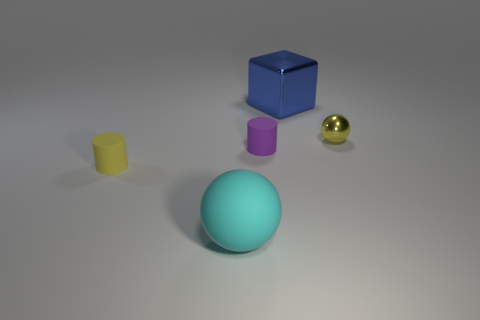What objects are in the foreground of the image? In the foreground of the image, we can see a large turquoise sphere prominently displayed at the center. 